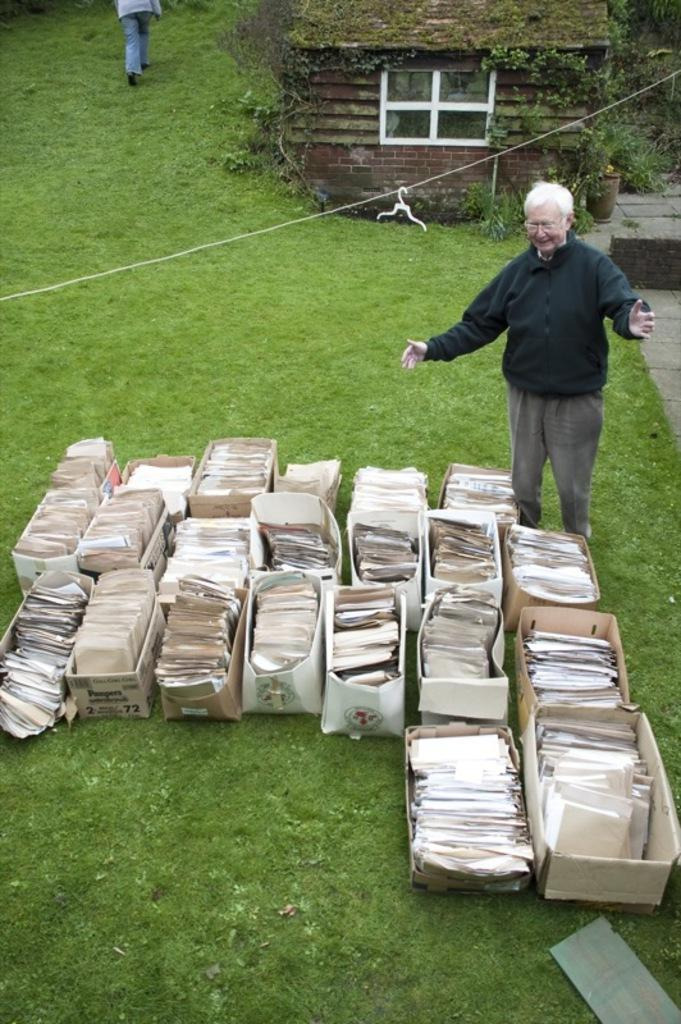What is inside the boxes in the image? There are objects in boxes in the image, but the specific contents are not mentioned. Can you describe the people in the background of the image? There are two people standing in the background of the image, but their appearance or actions are not described. What can be seen through the window in the image? The provided facts do not mention what can be seen through the window. Where is the flower pot located in the image? The flower pot is in the image, but its exact location is not specified. What type of plants are visible in the image? There are plants in the image, but their specific type is not mentioned. What is the texture of the grass visible in the image? The provided facts do not mention the texture of the grass. What color is the dad's hair in the image? There is no mention of a dad or hair in the image. What is the range of the objects in the boxes in the image? The provided facts do not mention the range or size of the objects in the boxes. 